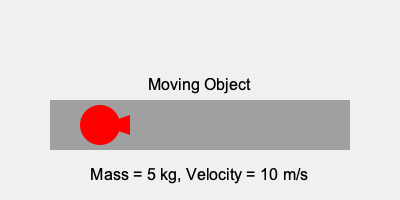In your arcade machine project, you're creating a game that simulates objects in motion. If a game object has a mass of 5 kg and is moving at a velocity of 10 m/s, what is its momentum? To calculate the momentum of a moving object, we use the formula:

$$ p = m \cdot v $$

Where:
$p$ = momentum (kg⋅m/s)
$m$ = mass (kg)
$v$ = velocity (m/s)

Given:
Mass ($m$) = 5 kg
Velocity ($v$) = 10 m/s

Let's substitute these values into the formula:

$$ p = 5 \text{ kg} \cdot 10 \text{ m/s} $$

Now, we simply multiply:

$$ p = 50 \text{ kg}\cdot\text{m/s} $$

Therefore, the momentum of the game object is 50 kg⋅m/s.
Answer: 50 kg⋅m/s 